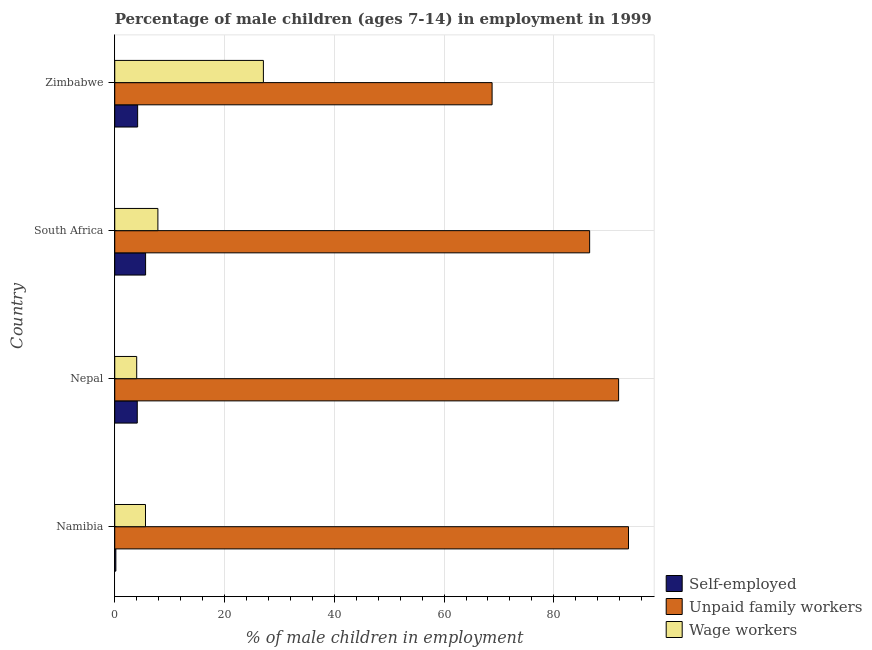Are the number of bars on each tick of the Y-axis equal?
Provide a succinct answer. Yes. How many bars are there on the 2nd tick from the bottom?
Your answer should be compact. 3. What is the label of the 1st group of bars from the top?
Keep it short and to the point. Zimbabwe. What is the percentage of children employed as unpaid family workers in Zimbabwe?
Provide a short and direct response. 68.75. Across all countries, what is the maximum percentage of self employed children?
Ensure brevity in your answer.  5.62. Across all countries, what is the minimum percentage of children employed as unpaid family workers?
Make the answer very short. 68.75. In which country was the percentage of self employed children maximum?
Keep it short and to the point. South Africa. In which country was the percentage of children employed as unpaid family workers minimum?
Offer a terse response. Zimbabwe. What is the total percentage of children employed as wage workers in the graph?
Keep it short and to the point. 44.54. What is the difference between the percentage of children employed as unpaid family workers in Nepal and that in South Africa?
Offer a terse response. 5.28. What is the difference between the percentage of self employed children in South Africa and the percentage of children employed as unpaid family workers in Namibia?
Ensure brevity in your answer.  -87.98. What is the average percentage of children employed as unpaid family workers per country?
Give a very brief answer. 85.17. What is the difference between the percentage of self employed children and percentage of children employed as unpaid family workers in Nepal?
Ensure brevity in your answer.  -87.7. In how many countries, is the percentage of children employed as wage workers greater than 92 %?
Provide a short and direct response. 0. What is the ratio of the percentage of children employed as unpaid family workers in Namibia to that in South Africa?
Offer a very short reply. 1.08. Is the percentage of children employed as unpaid family workers in Namibia less than that in Nepal?
Offer a terse response. No. Is the difference between the percentage of children employed as unpaid family workers in South Africa and Zimbabwe greater than the difference between the percentage of children employed as wage workers in South Africa and Zimbabwe?
Provide a succinct answer. Yes. What is the difference between the highest and the second highest percentage of children employed as wage workers?
Make the answer very short. 19.22. What is the difference between the highest and the lowest percentage of children employed as wage workers?
Ensure brevity in your answer.  23.08. In how many countries, is the percentage of self employed children greater than the average percentage of self employed children taken over all countries?
Provide a succinct answer. 3. What does the 3rd bar from the top in Nepal represents?
Provide a short and direct response. Self-employed. What does the 2nd bar from the bottom in Zimbabwe represents?
Offer a terse response. Unpaid family workers. Is it the case that in every country, the sum of the percentage of self employed children and percentage of children employed as unpaid family workers is greater than the percentage of children employed as wage workers?
Your response must be concise. Yes. How many bars are there?
Your answer should be compact. 12. Are all the bars in the graph horizontal?
Your answer should be very brief. Yes. How many countries are there in the graph?
Keep it short and to the point. 4. What is the difference between two consecutive major ticks on the X-axis?
Your answer should be very brief. 20. Does the graph contain grids?
Offer a very short reply. Yes. Where does the legend appear in the graph?
Your answer should be compact. Bottom right. What is the title of the graph?
Your answer should be compact. Percentage of male children (ages 7-14) in employment in 1999. What is the label or title of the X-axis?
Offer a terse response. % of male children in employment. What is the label or title of the Y-axis?
Ensure brevity in your answer.  Country. What is the % of male children in employment in Unpaid family workers in Namibia?
Offer a terse response. 93.6. What is the % of male children in employment of Self-employed in Nepal?
Your answer should be very brief. 4.1. What is the % of male children in employment in Unpaid family workers in Nepal?
Keep it short and to the point. 91.8. What is the % of male children in employment in Self-employed in South Africa?
Your response must be concise. 5.62. What is the % of male children in employment in Unpaid family workers in South Africa?
Offer a very short reply. 86.52. What is the % of male children in employment in Wage workers in South Africa?
Give a very brief answer. 7.86. What is the % of male children in employment in Self-employed in Zimbabwe?
Your answer should be compact. 4.17. What is the % of male children in employment in Unpaid family workers in Zimbabwe?
Make the answer very short. 68.75. What is the % of male children in employment of Wage workers in Zimbabwe?
Keep it short and to the point. 27.08. Across all countries, what is the maximum % of male children in employment of Self-employed?
Offer a terse response. 5.62. Across all countries, what is the maximum % of male children in employment of Unpaid family workers?
Your response must be concise. 93.6. Across all countries, what is the maximum % of male children in employment of Wage workers?
Provide a succinct answer. 27.08. Across all countries, what is the minimum % of male children in employment of Self-employed?
Provide a short and direct response. 0.2. Across all countries, what is the minimum % of male children in employment of Unpaid family workers?
Offer a terse response. 68.75. What is the total % of male children in employment in Self-employed in the graph?
Your response must be concise. 14.09. What is the total % of male children in employment in Unpaid family workers in the graph?
Ensure brevity in your answer.  340.67. What is the total % of male children in employment of Wage workers in the graph?
Offer a terse response. 44.54. What is the difference between the % of male children in employment in Self-employed in Namibia and that in South Africa?
Ensure brevity in your answer.  -5.42. What is the difference between the % of male children in employment of Unpaid family workers in Namibia and that in South Africa?
Ensure brevity in your answer.  7.08. What is the difference between the % of male children in employment in Wage workers in Namibia and that in South Africa?
Provide a succinct answer. -2.26. What is the difference between the % of male children in employment in Self-employed in Namibia and that in Zimbabwe?
Provide a succinct answer. -3.97. What is the difference between the % of male children in employment of Unpaid family workers in Namibia and that in Zimbabwe?
Keep it short and to the point. 24.85. What is the difference between the % of male children in employment of Wage workers in Namibia and that in Zimbabwe?
Provide a short and direct response. -21.48. What is the difference between the % of male children in employment in Self-employed in Nepal and that in South Africa?
Your answer should be compact. -1.52. What is the difference between the % of male children in employment in Unpaid family workers in Nepal and that in South Africa?
Keep it short and to the point. 5.28. What is the difference between the % of male children in employment in Wage workers in Nepal and that in South Africa?
Your response must be concise. -3.86. What is the difference between the % of male children in employment of Self-employed in Nepal and that in Zimbabwe?
Your answer should be very brief. -0.07. What is the difference between the % of male children in employment in Unpaid family workers in Nepal and that in Zimbabwe?
Your response must be concise. 23.05. What is the difference between the % of male children in employment in Wage workers in Nepal and that in Zimbabwe?
Provide a short and direct response. -23.08. What is the difference between the % of male children in employment in Self-employed in South Africa and that in Zimbabwe?
Your response must be concise. 1.45. What is the difference between the % of male children in employment of Unpaid family workers in South Africa and that in Zimbabwe?
Keep it short and to the point. 17.77. What is the difference between the % of male children in employment in Wage workers in South Africa and that in Zimbabwe?
Keep it short and to the point. -19.22. What is the difference between the % of male children in employment of Self-employed in Namibia and the % of male children in employment of Unpaid family workers in Nepal?
Keep it short and to the point. -91.6. What is the difference between the % of male children in employment of Unpaid family workers in Namibia and the % of male children in employment of Wage workers in Nepal?
Ensure brevity in your answer.  89.6. What is the difference between the % of male children in employment in Self-employed in Namibia and the % of male children in employment in Unpaid family workers in South Africa?
Provide a succinct answer. -86.32. What is the difference between the % of male children in employment of Self-employed in Namibia and the % of male children in employment of Wage workers in South Africa?
Provide a short and direct response. -7.66. What is the difference between the % of male children in employment in Unpaid family workers in Namibia and the % of male children in employment in Wage workers in South Africa?
Your answer should be very brief. 85.74. What is the difference between the % of male children in employment of Self-employed in Namibia and the % of male children in employment of Unpaid family workers in Zimbabwe?
Provide a succinct answer. -68.55. What is the difference between the % of male children in employment in Self-employed in Namibia and the % of male children in employment in Wage workers in Zimbabwe?
Keep it short and to the point. -26.88. What is the difference between the % of male children in employment in Unpaid family workers in Namibia and the % of male children in employment in Wage workers in Zimbabwe?
Provide a succinct answer. 66.52. What is the difference between the % of male children in employment of Self-employed in Nepal and the % of male children in employment of Unpaid family workers in South Africa?
Offer a very short reply. -82.42. What is the difference between the % of male children in employment of Self-employed in Nepal and the % of male children in employment of Wage workers in South Africa?
Provide a succinct answer. -3.76. What is the difference between the % of male children in employment of Unpaid family workers in Nepal and the % of male children in employment of Wage workers in South Africa?
Provide a succinct answer. 83.94. What is the difference between the % of male children in employment of Self-employed in Nepal and the % of male children in employment of Unpaid family workers in Zimbabwe?
Your answer should be compact. -64.65. What is the difference between the % of male children in employment in Self-employed in Nepal and the % of male children in employment in Wage workers in Zimbabwe?
Give a very brief answer. -22.98. What is the difference between the % of male children in employment of Unpaid family workers in Nepal and the % of male children in employment of Wage workers in Zimbabwe?
Provide a short and direct response. 64.72. What is the difference between the % of male children in employment of Self-employed in South Africa and the % of male children in employment of Unpaid family workers in Zimbabwe?
Offer a terse response. -63.13. What is the difference between the % of male children in employment in Self-employed in South Africa and the % of male children in employment in Wage workers in Zimbabwe?
Provide a short and direct response. -21.46. What is the difference between the % of male children in employment in Unpaid family workers in South Africa and the % of male children in employment in Wage workers in Zimbabwe?
Give a very brief answer. 59.44. What is the average % of male children in employment in Self-employed per country?
Give a very brief answer. 3.52. What is the average % of male children in employment of Unpaid family workers per country?
Offer a terse response. 85.17. What is the average % of male children in employment in Wage workers per country?
Offer a very short reply. 11.13. What is the difference between the % of male children in employment in Self-employed and % of male children in employment in Unpaid family workers in Namibia?
Ensure brevity in your answer.  -93.4. What is the difference between the % of male children in employment in Self-employed and % of male children in employment in Wage workers in Namibia?
Provide a succinct answer. -5.4. What is the difference between the % of male children in employment of Unpaid family workers and % of male children in employment of Wage workers in Namibia?
Offer a terse response. 88. What is the difference between the % of male children in employment of Self-employed and % of male children in employment of Unpaid family workers in Nepal?
Your answer should be compact. -87.7. What is the difference between the % of male children in employment of Unpaid family workers and % of male children in employment of Wage workers in Nepal?
Your answer should be very brief. 87.8. What is the difference between the % of male children in employment in Self-employed and % of male children in employment in Unpaid family workers in South Africa?
Provide a short and direct response. -80.9. What is the difference between the % of male children in employment of Self-employed and % of male children in employment of Wage workers in South Africa?
Offer a terse response. -2.24. What is the difference between the % of male children in employment in Unpaid family workers and % of male children in employment in Wage workers in South Africa?
Offer a terse response. 78.66. What is the difference between the % of male children in employment in Self-employed and % of male children in employment in Unpaid family workers in Zimbabwe?
Provide a succinct answer. -64.58. What is the difference between the % of male children in employment of Self-employed and % of male children in employment of Wage workers in Zimbabwe?
Provide a succinct answer. -22.91. What is the difference between the % of male children in employment of Unpaid family workers and % of male children in employment of Wage workers in Zimbabwe?
Provide a short and direct response. 41.67. What is the ratio of the % of male children in employment of Self-employed in Namibia to that in Nepal?
Make the answer very short. 0.05. What is the ratio of the % of male children in employment in Unpaid family workers in Namibia to that in Nepal?
Give a very brief answer. 1.02. What is the ratio of the % of male children in employment of Wage workers in Namibia to that in Nepal?
Ensure brevity in your answer.  1.4. What is the ratio of the % of male children in employment in Self-employed in Namibia to that in South Africa?
Provide a short and direct response. 0.04. What is the ratio of the % of male children in employment in Unpaid family workers in Namibia to that in South Africa?
Offer a terse response. 1.08. What is the ratio of the % of male children in employment of Wage workers in Namibia to that in South Africa?
Offer a terse response. 0.71. What is the ratio of the % of male children in employment in Self-employed in Namibia to that in Zimbabwe?
Make the answer very short. 0.05. What is the ratio of the % of male children in employment of Unpaid family workers in Namibia to that in Zimbabwe?
Your answer should be very brief. 1.36. What is the ratio of the % of male children in employment in Wage workers in Namibia to that in Zimbabwe?
Make the answer very short. 0.21. What is the ratio of the % of male children in employment of Self-employed in Nepal to that in South Africa?
Provide a succinct answer. 0.73. What is the ratio of the % of male children in employment of Unpaid family workers in Nepal to that in South Africa?
Offer a terse response. 1.06. What is the ratio of the % of male children in employment in Wage workers in Nepal to that in South Africa?
Make the answer very short. 0.51. What is the ratio of the % of male children in employment of Self-employed in Nepal to that in Zimbabwe?
Ensure brevity in your answer.  0.98. What is the ratio of the % of male children in employment of Unpaid family workers in Nepal to that in Zimbabwe?
Your answer should be very brief. 1.34. What is the ratio of the % of male children in employment in Wage workers in Nepal to that in Zimbabwe?
Offer a terse response. 0.15. What is the ratio of the % of male children in employment in Self-employed in South Africa to that in Zimbabwe?
Your response must be concise. 1.35. What is the ratio of the % of male children in employment in Unpaid family workers in South Africa to that in Zimbabwe?
Your answer should be compact. 1.26. What is the ratio of the % of male children in employment of Wage workers in South Africa to that in Zimbabwe?
Your answer should be very brief. 0.29. What is the difference between the highest and the second highest % of male children in employment of Self-employed?
Your response must be concise. 1.45. What is the difference between the highest and the second highest % of male children in employment in Unpaid family workers?
Provide a succinct answer. 1.8. What is the difference between the highest and the second highest % of male children in employment in Wage workers?
Provide a short and direct response. 19.22. What is the difference between the highest and the lowest % of male children in employment of Self-employed?
Provide a short and direct response. 5.42. What is the difference between the highest and the lowest % of male children in employment in Unpaid family workers?
Provide a succinct answer. 24.85. What is the difference between the highest and the lowest % of male children in employment in Wage workers?
Your answer should be very brief. 23.08. 